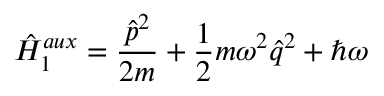Convert formula to latex. <formula><loc_0><loc_0><loc_500><loc_500>\hat { H } _ { 1 } ^ { a u x } = \frac { \hat { p } ^ { 2 } } { 2 m } + \frac { 1 } { 2 } m \omega ^ { 2 } \hat { q } ^ { 2 } + \hbar { \omega }</formula> 